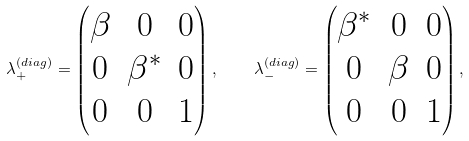Convert formula to latex. <formula><loc_0><loc_0><loc_500><loc_500>\lambda _ { + } ^ { ( d i a g ) } = \begin{pmatrix} \beta & 0 & 0 \\ 0 & \beta ^ { * } & 0 \\ 0 & 0 & 1 \end{pmatrix} , \quad \lambda _ { - } ^ { ( d i a g ) } = \begin{pmatrix} \beta ^ { * } & 0 & 0 \\ 0 & \beta & 0 \\ 0 & 0 & 1 \end{pmatrix} ,</formula> 